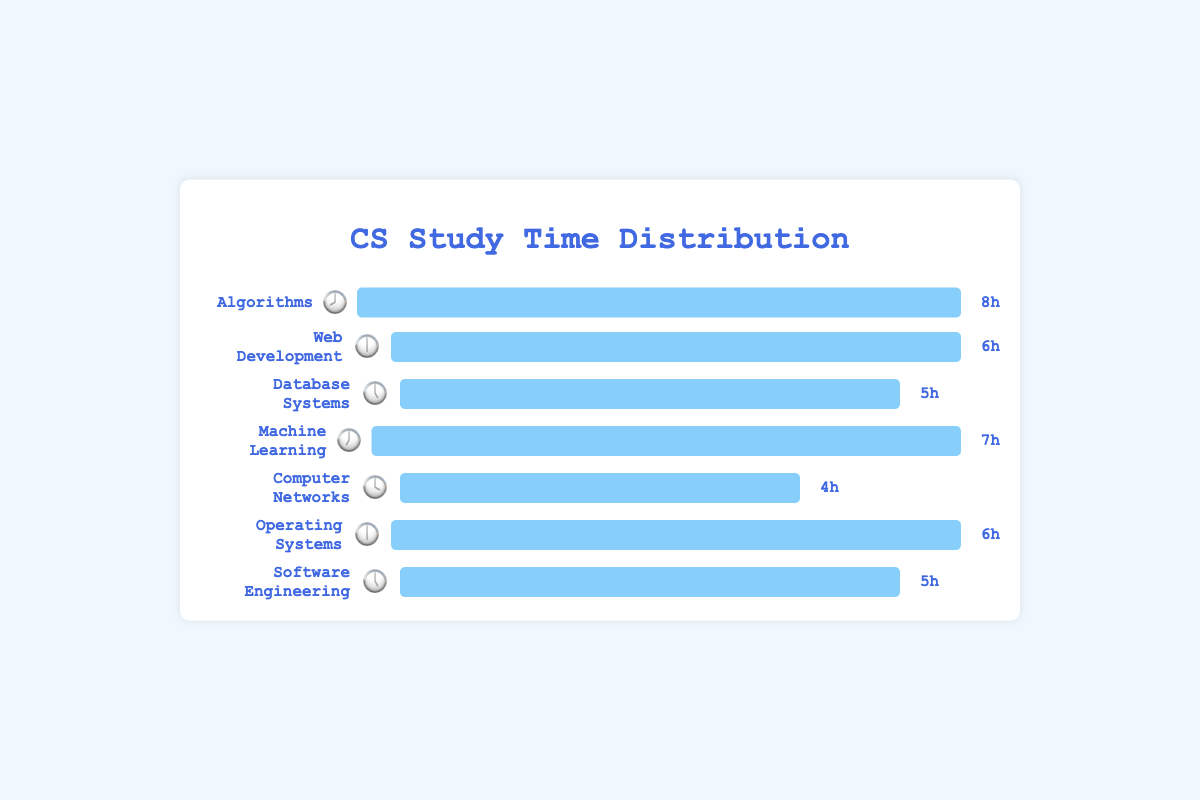What is the title of the figure? The text at the top of the figure is clearly labeled as the title.
Answer: CS Study Time Distribution Which subject has the highest number of study hours? By observing the lengths of the bars, Algorithms has the longest bar, indicating it has the highest number of study hours.
Answer: Algorithms What is the total number of study hours for all subjects combined? Sum of all subjects' hours: 8 (Algorithms) + 6 (Web Development) + 5 (Database Systems) + 7 (Machine Learning) + 4 (Computer Networks) + 6 (Operating Systems) + 5 (Software Engineering) = 41
Answer: 41 What emoji represents "Machine Learning"? The emoji next to "Machine Learning" in the figure is 🕖.
Answer: 🕖 Which subject has fewer study hours: "Computer Networks" or "Database Systems"? Computer Networks has 4 hours while Database Systems has 5 hours, so Computer Networks has fewer study hours.
Answer: Computer Networks How many more study hours are spent on "Web Development" compared to "Computer Networks"? Web Development has 6 hours and Computer Networks has 4 hours. Difference is 6 - 4.
Answer: 2 What is the average number of study hours across all subjects? Total hours: 41. Number of subjects: 7. Average = 41 / 7.
Answer: 5.86 Which subjects have the same number of study hours? By comparing the lengths of the bars, Web Development and Operating Systems both have 6 study hours, and Database Systems and Software Engineering both have 5 study hours.
Answer: Web Development and Operating Systems, Database Systems and Software Engineering What is the color of the bars in the figure? The bars in the figure are filled with a light blue color.
Answer: Light blue How many subjects have more than 5 study hours? Subjects with more than 5 hours: Algorithms (8), Machine Learning (7), Web Development (6), Operating Systems (6). Total subjects = 4.
Answer: 4 